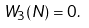<formula> <loc_0><loc_0><loc_500><loc_500>W _ { 3 } ( N ) = 0 .</formula> 